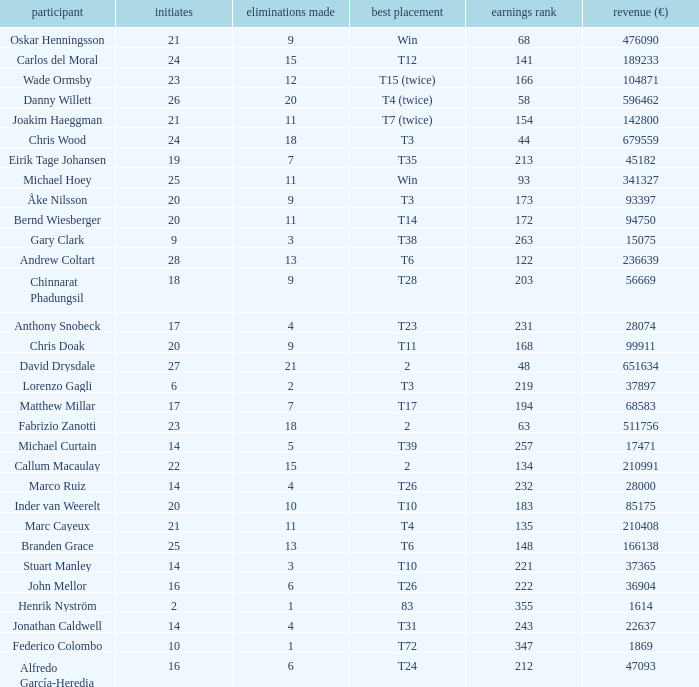How many cuts did Gary Clark make? 3.0. 